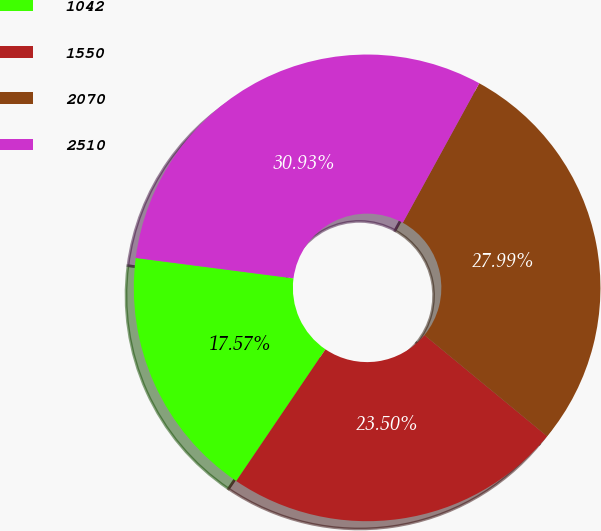Convert chart. <chart><loc_0><loc_0><loc_500><loc_500><pie_chart><fcel>1042<fcel>1550<fcel>2070<fcel>2510<nl><fcel>17.57%<fcel>23.5%<fcel>27.99%<fcel>30.93%<nl></chart> 